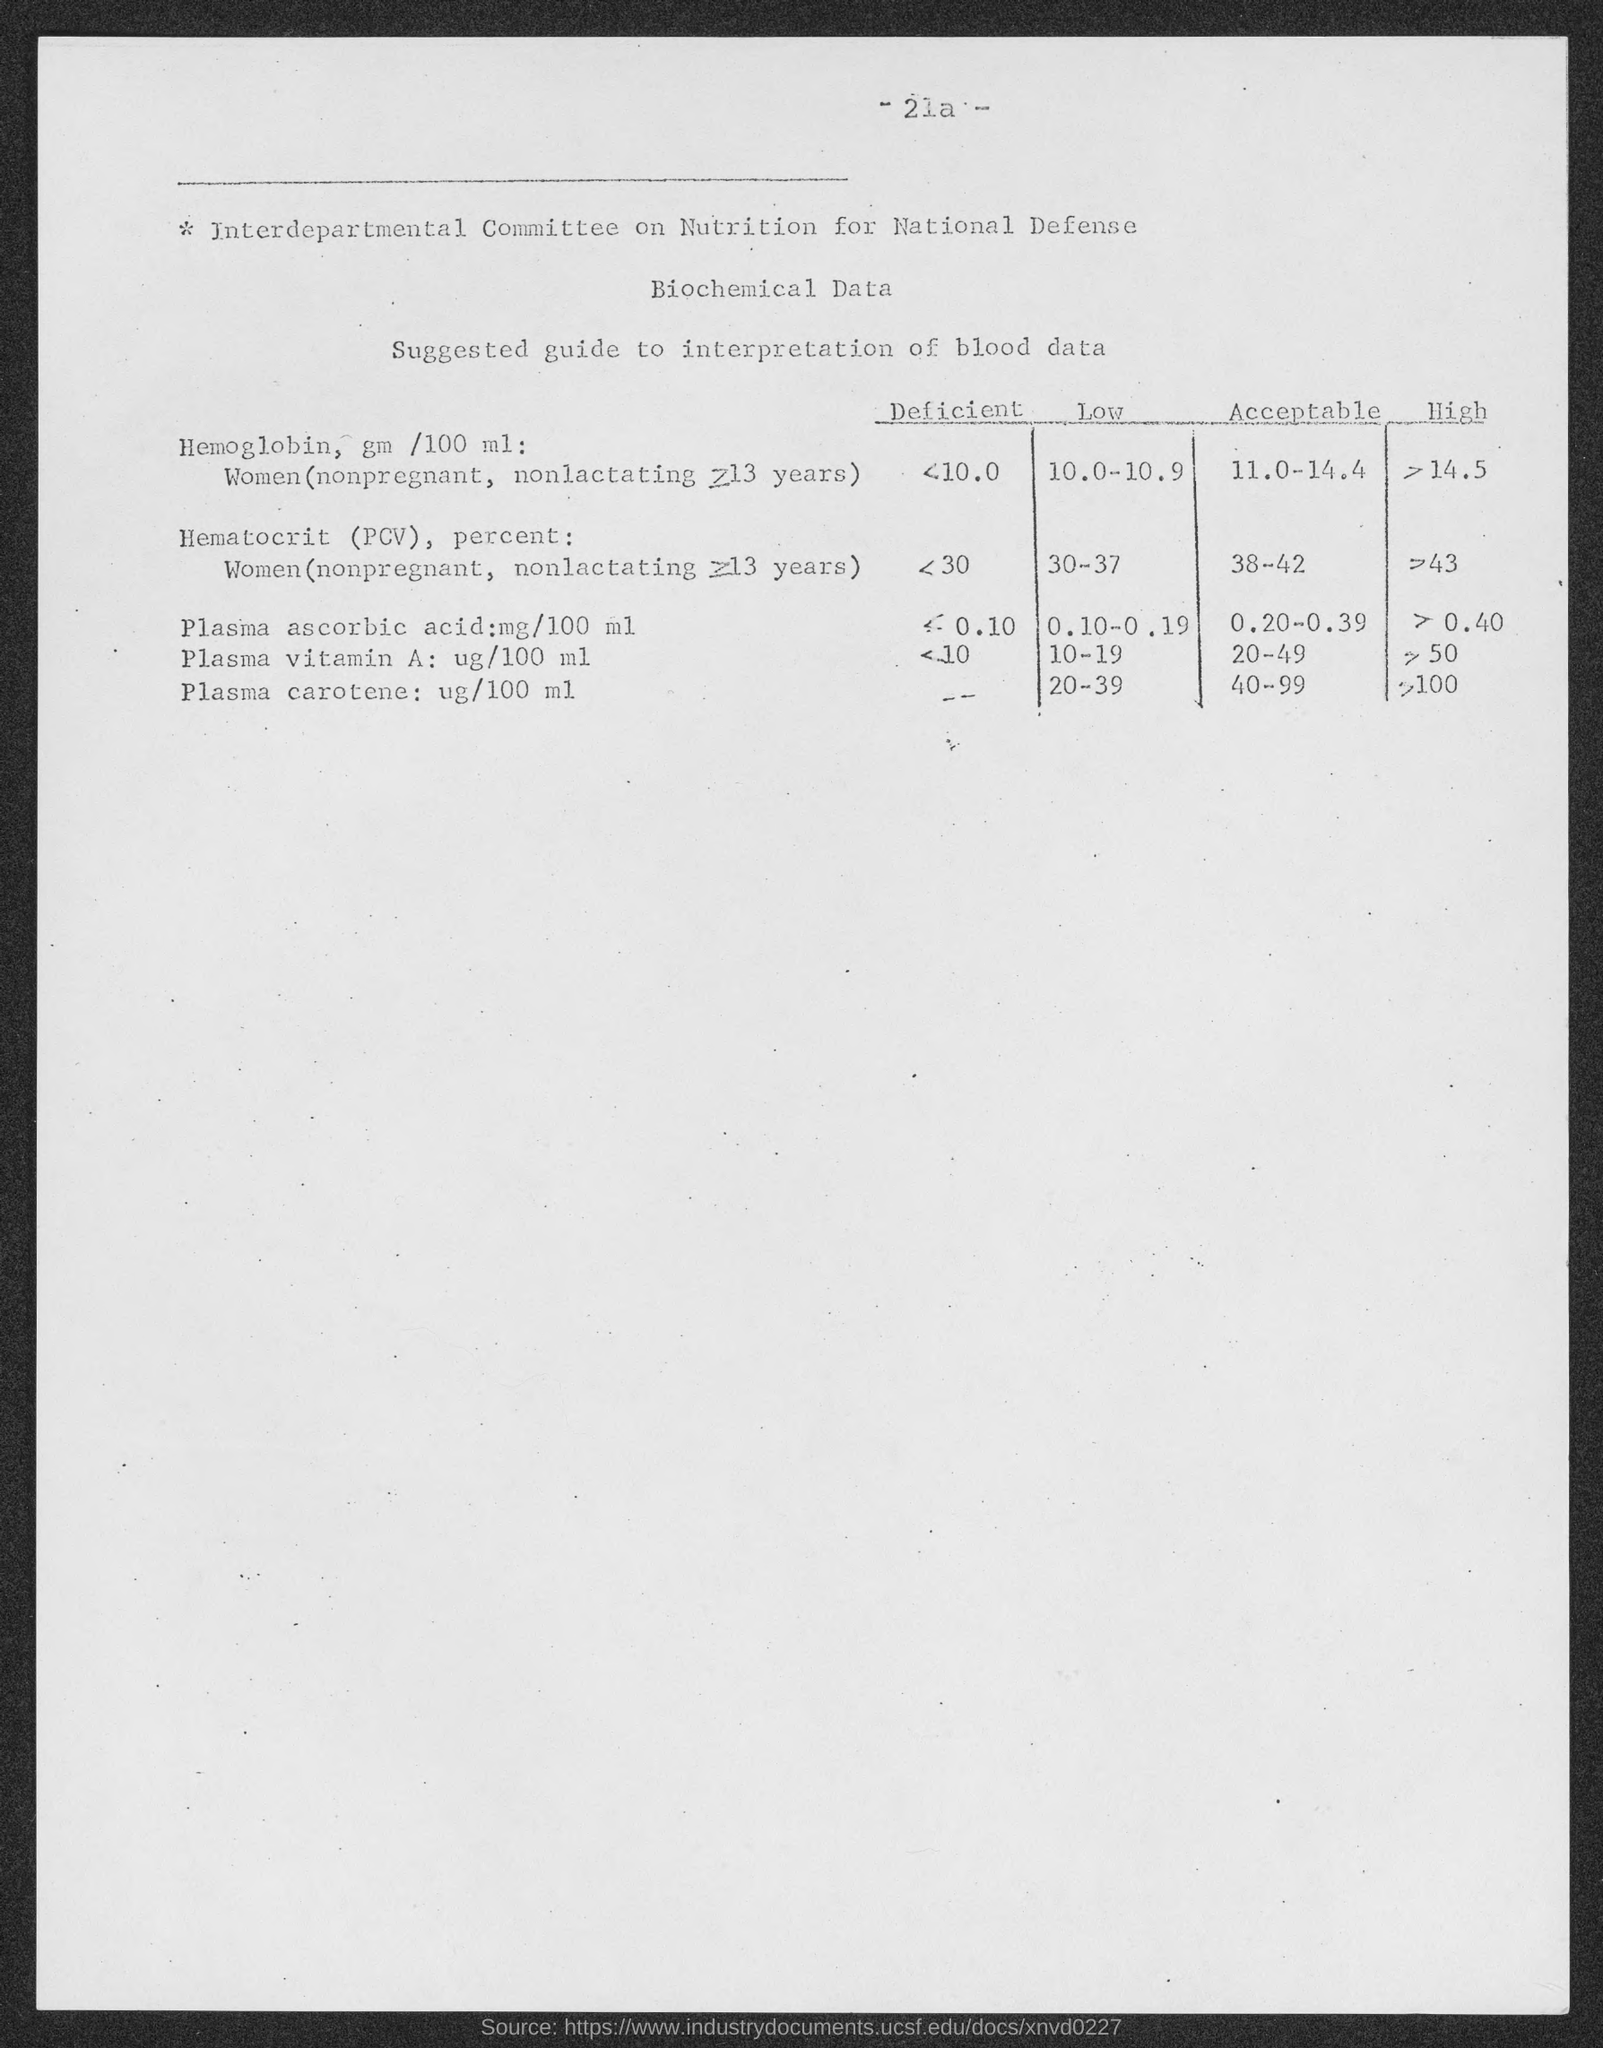What is the page number?
Offer a very short reply. - 21a -. 